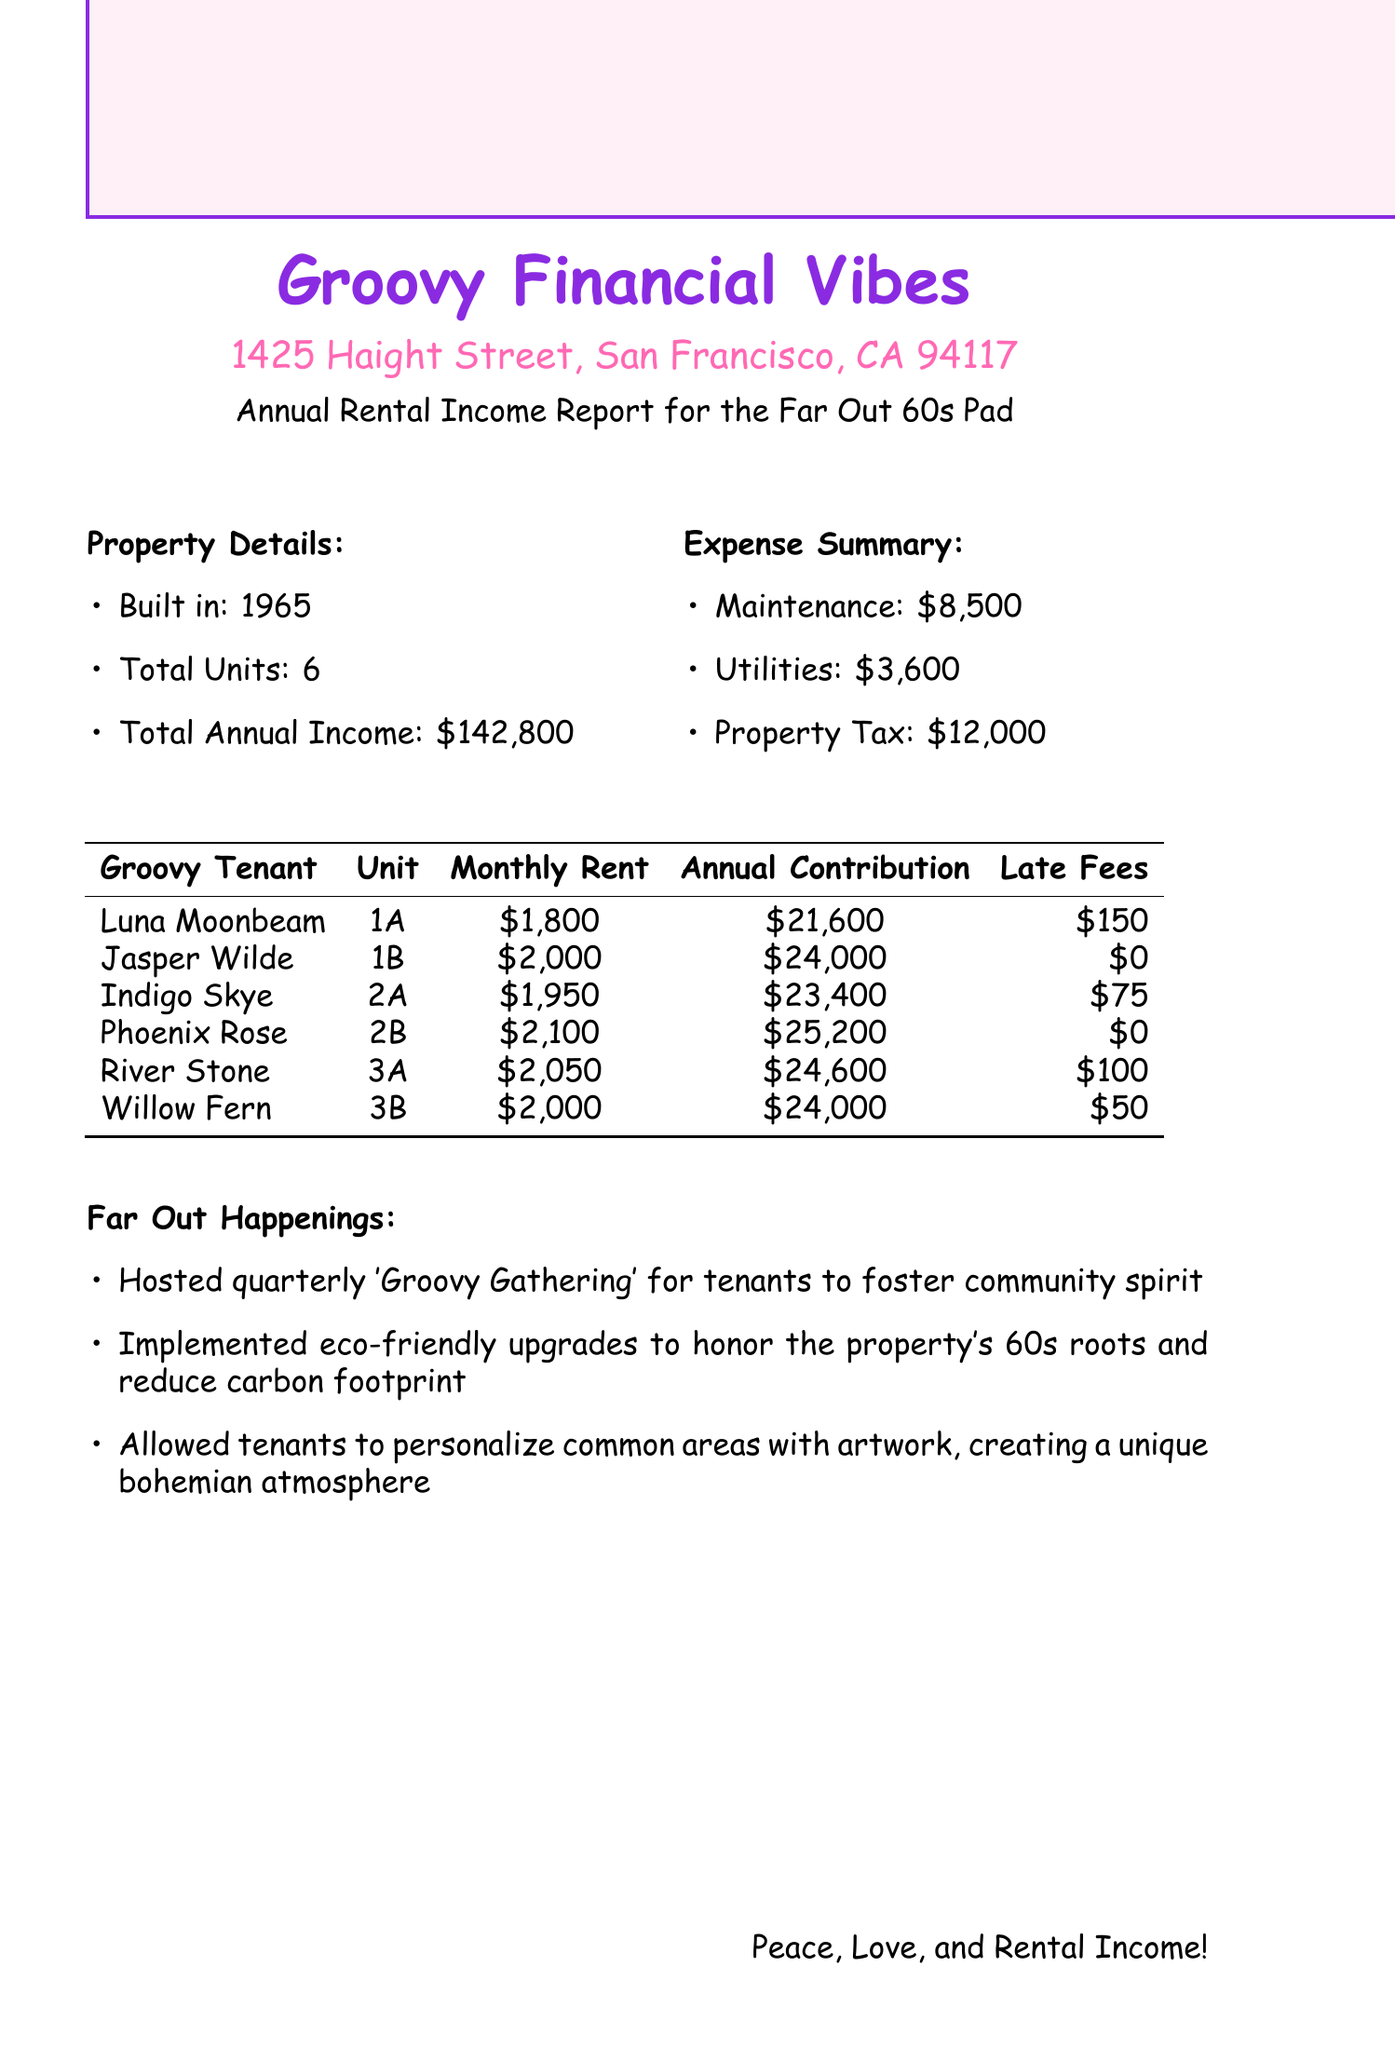What is the total annual rental income? The total annual rental income is explicitly stated in the document as \$142,800.
Answer: \$142,800 Who is the tenant in unit 2A? The tenant in unit 2A is listed in the table that specifies the tenant's details, and it shows that Indigo Skye occupies this unit.
Answer: Indigo Skye What is the late fee for Luna Moonbeam? The document lists late fees for each tenant, indicating that Luna Moonbeam has a late fee of \$150.
Answer: \$150 How much does Phoenix Rose contribute annually? The annual contribution for Phoenix Rose is provided in the table, and it shows that her contribution is \$25,200.
Answer: \$25,200 What was the property tax expense? The expense summary in the document outlines various spending categories, showing the property tax as \$12,000.
Answer: \$12,000 Which tenant has the highest monthly rent? By comparing the monthly rent for all tenants in the document, it can be determined that Phoenix Rose has the highest monthly rent of \$2,100.
Answer: \$2,100 How many total units are in the property? The number of total units is stated in the property details section, confirming that there are 6 total units.
Answer: 6 What notable community event is hosted quarterly? The document mentions a community event called the 'Groovy Gathering' that is hosted for tenants to enhance community spirit.
Answer: Groovy Gathering What is one way the property honors its 60s roots? The additional notes indicate that eco-friendly upgrades have been implemented to honor the property's 60s roots and reduce carbon footprint.
Answer: Eco-friendly upgrades 